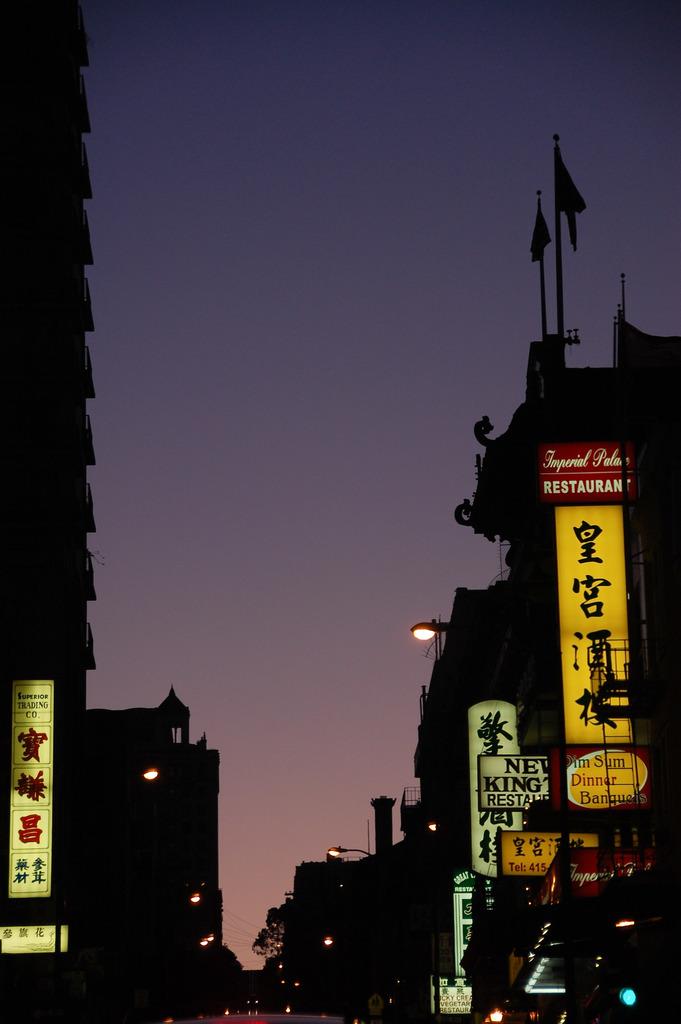What is the restaurant called?
Give a very brief answer. Imperial palace. What is the restaurant sign in red?
Your answer should be very brief. Imperial palace. 